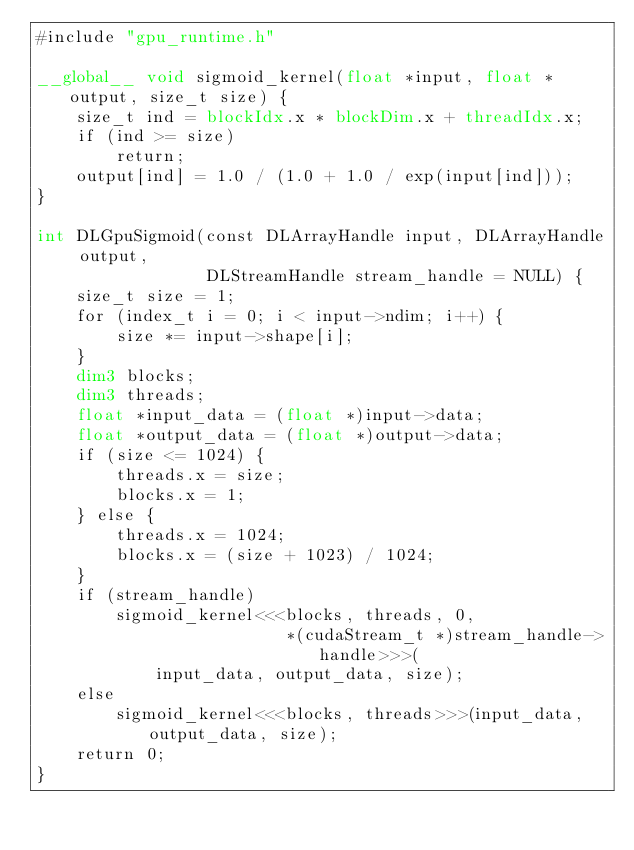Convert code to text. <code><loc_0><loc_0><loc_500><loc_500><_Cuda_>#include "gpu_runtime.h"

__global__ void sigmoid_kernel(float *input, float *output, size_t size) {
    size_t ind = blockIdx.x * blockDim.x + threadIdx.x;
    if (ind >= size)
        return;
    output[ind] = 1.0 / (1.0 + 1.0 / exp(input[ind]));
}

int DLGpuSigmoid(const DLArrayHandle input, DLArrayHandle output,
                 DLStreamHandle stream_handle = NULL) {
    size_t size = 1;
    for (index_t i = 0; i < input->ndim; i++) {
        size *= input->shape[i];
    }
    dim3 blocks;
    dim3 threads;
    float *input_data = (float *)input->data;
    float *output_data = (float *)output->data;
    if (size <= 1024) {
        threads.x = size;
        blocks.x = 1;
    } else {
        threads.x = 1024;
        blocks.x = (size + 1023) / 1024;
    }
    if (stream_handle)
        sigmoid_kernel<<<blocks, threads, 0,
                         *(cudaStream_t *)stream_handle->handle>>>(
            input_data, output_data, size);
    else
        sigmoid_kernel<<<blocks, threads>>>(input_data, output_data, size);
    return 0;
}</code> 